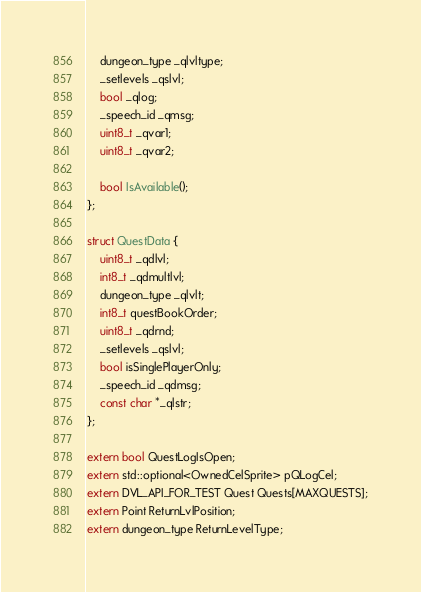Convert code to text. <code><loc_0><loc_0><loc_500><loc_500><_C_>	dungeon_type _qlvltype;
	_setlevels _qslvl;
	bool _qlog;
	_speech_id _qmsg;
	uint8_t _qvar1;
	uint8_t _qvar2;

	bool IsAvailable();
};

struct QuestData {
	uint8_t _qdlvl;
	int8_t _qdmultlvl;
	dungeon_type _qlvlt;
	int8_t questBookOrder;
	uint8_t _qdrnd;
	_setlevels _qslvl;
	bool isSinglePlayerOnly;
	_speech_id _qdmsg;
	const char *_qlstr;
};

extern bool QuestLogIsOpen;
extern std::optional<OwnedCelSprite> pQLogCel;
extern DVL_API_FOR_TEST Quest Quests[MAXQUESTS];
extern Point ReturnLvlPosition;
extern dungeon_type ReturnLevelType;</code> 